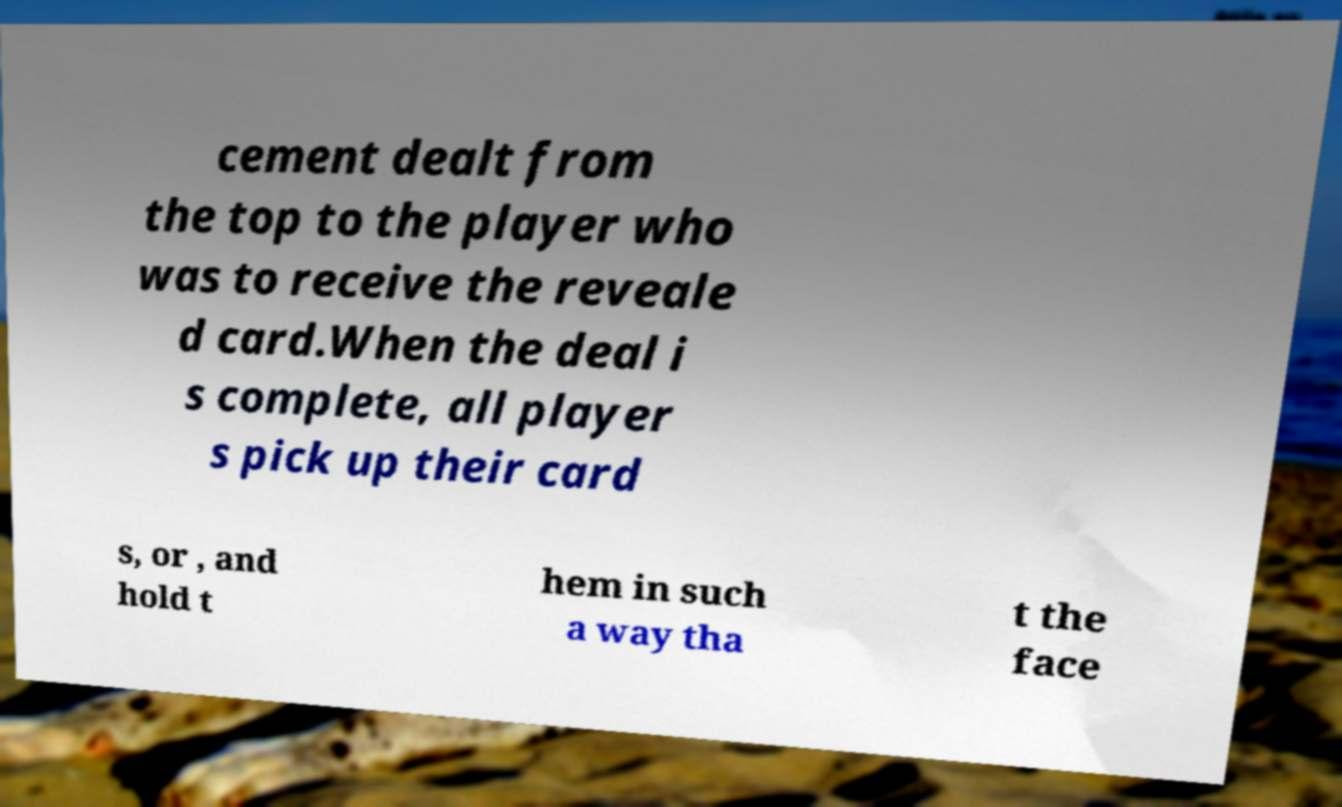Can you read and provide the text displayed in the image?This photo seems to have some interesting text. Can you extract and type it out for me? cement dealt from the top to the player who was to receive the reveale d card.When the deal i s complete, all player s pick up their card s, or , and hold t hem in such a way tha t the face 